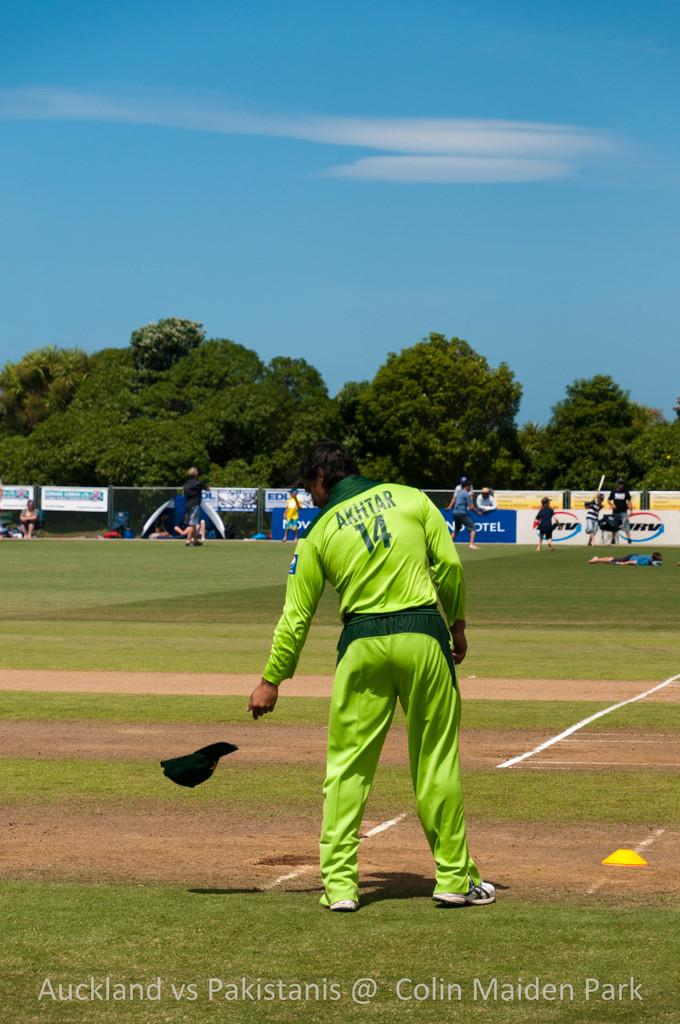<image>
Summarize the visual content of the image. A man in a green outfit that says Akhtar on the back throws his hat on the ground. 